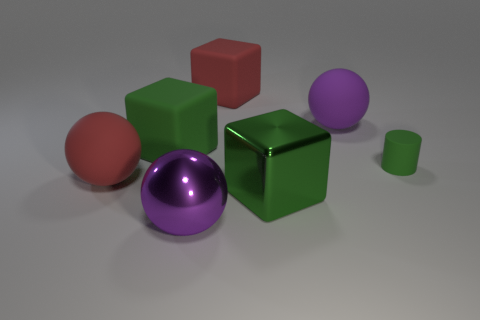Add 2 big red cubes. How many objects exist? 9 Subtract all balls. How many objects are left? 4 Add 6 big metal things. How many big metal things are left? 8 Add 3 big cyan cylinders. How many big cyan cylinders exist? 3 Subtract 0 purple cylinders. How many objects are left? 7 Subtract all green blocks. Subtract all purple shiny spheres. How many objects are left? 4 